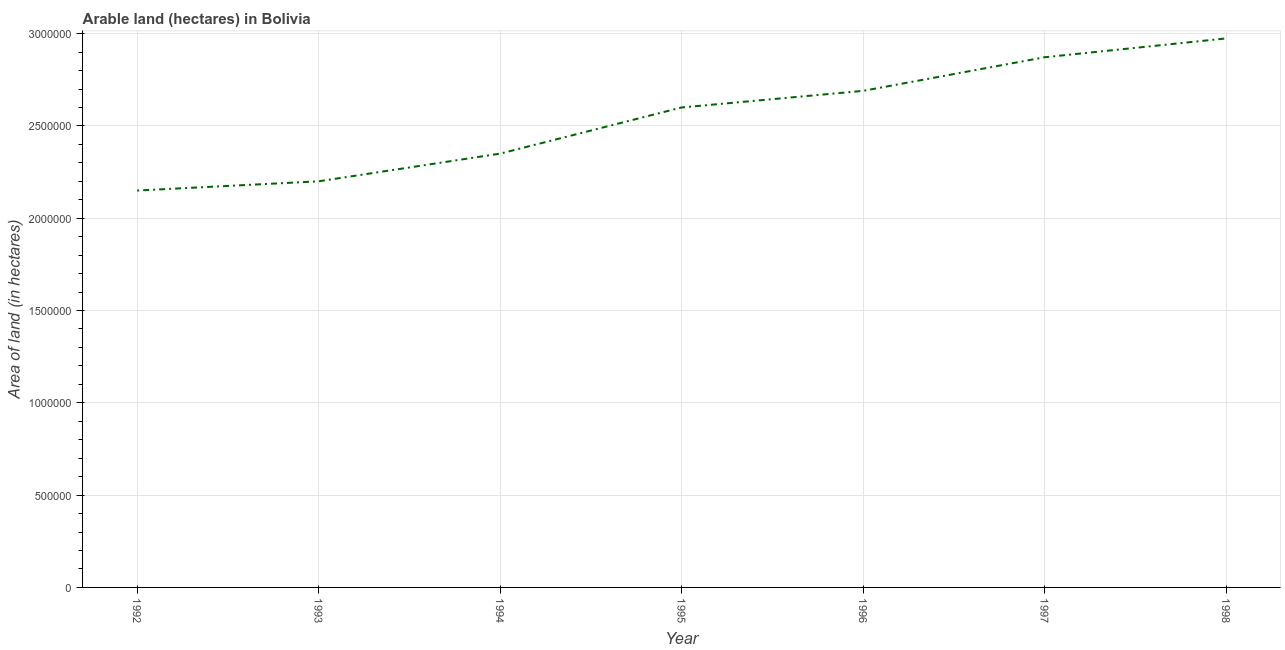What is the area of land in 1993?
Offer a very short reply. 2.20e+06. Across all years, what is the maximum area of land?
Make the answer very short. 2.97e+06. Across all years, what is the minimum area of land?
Your response must be concise. 2.15e+06. What is the sum of the area of land?
Your answer should be compact. 1.78e+07. What is the difference between the area of land in 1993 and 1996?
Your response must be concise. -4.90e+05. What is the average area of land per year?
Offer a terse response. 2.55e+06. What is the median area of land?
Your answer should be compact. 2.60e+06. Do a majority of the years between 1995 and 1994 (inclusive) have area of land greater than 1700000 hectares?
Keep it short and to the point. No. What is the ratio of the area of land in 1992 to that in 1996?
Offer a very short reply. 0.8. What is the difference between the highest and the second highest area of land?
Keep it short and to the point. 1.02e+05. Is the sum of the area of land in 1993 and 1996 greater than the maximum area of land across all years?
Your answer should be compact. Yes. What is the difference between the highest and the lowest area of land?
Provide a succinct answer. 8.24e+05. In how many years, is the area of land greater than the average area of land taken over all years?
Give a very brief answer. 4. Does the area of land monotonically increase over the years?
Give a very brief answer. Yes. How many lines are there?
Provide a short and direct response. 1. Are the values on the major ticks of Y-axis written in scientific E-notation?
Provide a short and direct response. No. Does the graph contain grids?
Keep it short and to the point. Yes. What is the title of the graph?
Provide a short and direct response. Arable land (hectares) in Bolivia. What is the label or title of the Y-axis?
Provide a short and direct response. Area of land (in hectares). What is the Area of land (in hectares) of 1992?
Provide a succinct answer. 2.15e+06. What is the Area of land (in hectares) in 1993?
Give a very brief answer. 2.20e+06. What is the Area of land (in hectares) of 1994?
Make the answer very short. 2.35e+06. What is the Area of land (in hectares) in 1995?
Ensure brevity in your answer.  2.60e+06. What is the Area of land (in hectares) of 1996?
Keep it short and to the point. 2.69e+06. What is the Area of land (in hectares) of 1997?
Your response must be concise. 2.87e+06. What is the Area of land (in hectares) of 1998?
Offer a very short reply. 2.97e+06. What is the difference between the Area of land (in hectares) in 1992 and 1993?
Your answer should be compact. -5.00e+04. What is the difference between the Area of land (in hectares) in 1992 and 1995?
Provide a short and direct response. -4.50e+05. What is the difference between the Area of land (in hectares) in 1992 and 1996?
Your answer should be compact. -5.40e+05. What is the difference between the Area of land (in hectares) in 1992 and 1997?
Keep it short and to the point. -7.22e+05. What is the difference between the Area of land (in hectares) in 1992 and 1998?
Your response must be concise. -8.24e+05. What is the difference between the Area of land (in hectares) in 1993 and 1995?
Ensure brevity in your answer.  -4.00e+05. What is the difference between the Area of land (in hectares) in 1993 and 1996?
Ensure brevity in your answer.  -4.90e+05. What is the difference between the Area of land (in hectares) in 1993 and 1997?
Provide a short and direct response. -6.72e+05. What is the difference between the Area of land (in hectares) in 1993 and 1998?
Offer a very short reply. -7.74e+05. What is the difference between the Area of land (in hectares) in 1994 and 1996?
Offer a very short reply. -3.40e+05. What is the difference between the Area of land (in hectares) in 1994 and 1997?
Provide a short and direct response. -5.22e+05. What is the difference between the Area of land (in hectares) in 1994 and 1998?
Give a very brief answer. -6.24e+05. What is the difference between the Area of land (in hectares) in 1995 and 1996?
Provide a short and direct response. -9.00e+04. What is the difference between the Area of land (in hectares) in 1995 and 1997?
Provide a short and direct response. -2.72e+05. What is the difference between the Area of land (in hectares) in 1995 and 1998?
Your answer should be very brief. -3.74e+05. What is the difference between the Area of land (in hectares) in 1996 and 1997?
Make the answer very short. -1.82e+05. What is the difference between the Area of land (in hectares) in 1996 and 1998?
Offer a very short reply. -2.84e+05. What is the difference between the Area of land (in hectares) in 1997 and 1998?
Keep it short and to the point. -1.02e+05. What is the ratio of the Area of land (in hectares) in 1992 to that in 1993?
Make the answer very short. 0.98. What is the ratio of the Area of land (in hectares) in 1992 to that in 1994?
Your answer should be very brief. 0.92. What is the ratio of the Area of land (in hectares) in 1992 to that in 1995?
Keep it short and to the point. 0.83. What is the ratio of the Area of land (in hectares) in 1992 to that in 1996?
Ensure brevity in your answer.  0.8. What is the ratio of the Area of land (in hectares) in 1992 to that in 1997?
Your answer should be very brief. 0.75. What is the ratio of the Area of land (in hectares) in 1992 to that in 1998?
Ensure brevity in your answer.  0.72. What is the ratio of the Area of land (in hectares) in 1993 to that in 1994?
Give a very brief answer. 0.94. What is the ratio of the Area of land (in hectares) in 1993 to that in 1995?
Provide a succinct answer. 0.85. What is the ratio of the Area of land (in hectares) in 1993 to that in 1996?
Keep it short and to the point. 0.82. What is the ratio of the Area of land (in hectares) in 1993 to that in 1997?
Provide a short and direct response. 0.77. What is the ratio of the Area of land (in hectares) in 1993 to that in 1998?
Ensure brevity in your answer.  0.74. What is the ratio of the Area of land (in hectares) in 1994 to that in 1995?
Provide a short and direct response. 0.9. What is the ratio of the Area of land (in hectares) in 1994 to that in 1996?
Your response must be concise. 0.87. What is the ratio of the Area of land (in hectares) in 1994 to that in 1997?
Your answer should be very brief. 0.82. What is the ratio of the Area of land (in hectares) in 1994 to that in 1998?
Your answer should be very brief. 0.79. What is the ratio of the Area of land (in hectares) in 1995 to that in 1997?
Give a very brief answer. 0.91. What is the ratio of the Area of land (in hectares) in 1995 to that in 1998?
Provide a succinct answer. 0.87. What is the ratio of the Area of land (in hectares) in 1996 to that in 1997?
Ensure brevity in your answer.  0.94. What is the ratio of the Area of land (in hectares) in 1996 to that in 1998?
Ensure brevity in your answer.  0.91. What is the ratio of the Area of land (in hectares) in 1997 to that in 1998?
Provide a short and direct response. 0.97. 